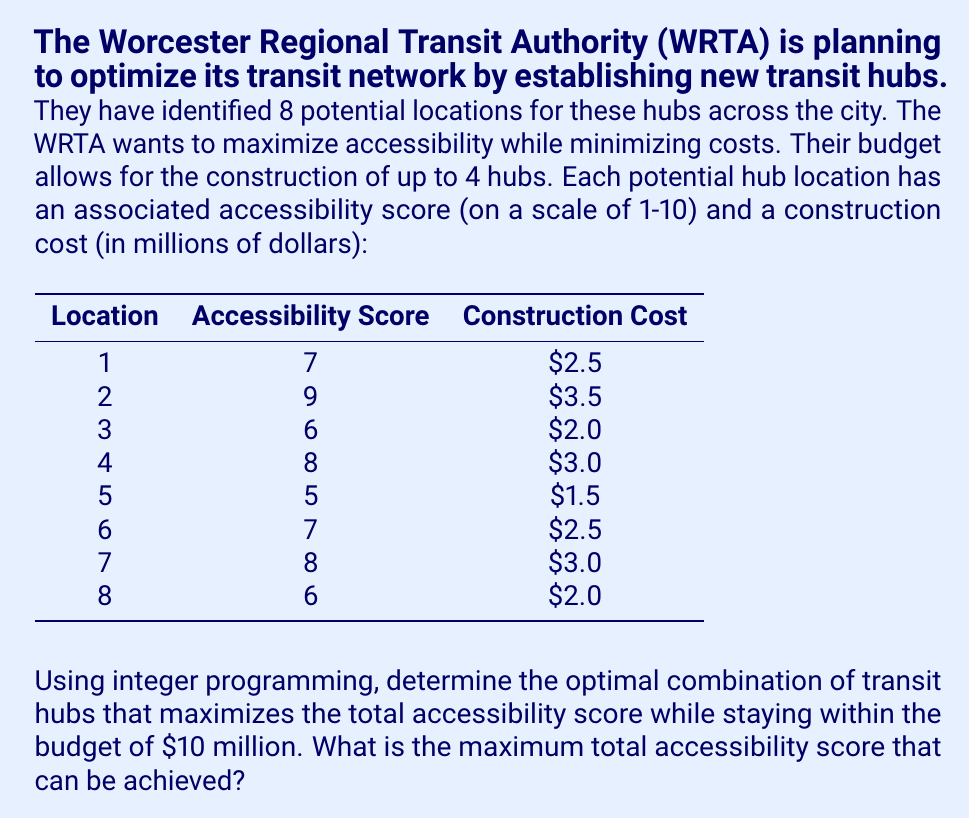Can you answer this question? To solve this problem, we'll use integer programming. Let's define our decision variables and formulate the problem:

Let $x_i$ be a binary variable for each location $i$ (1 if selected, 0 if not):

$$x_i \in \{0,1\}, \quad i = 1,2,\ldots,8$$

Objective function (maximize total accessibility score):

$$\text{Maximize } Z = 7x_1 + 9x_2 + 6x_3 + 8x_4 + 5x_5 + 7x_6 + 8x_7 + 6x_8$$

Constraints:

1. Budget constraint:
   $$2.5x_1 + 3.5x_2 + 2.0x_3 + 3.0x_4 + 1.5x_5 + 2.5x_6 + 3.0x_7 + 2.0x_8 \leq 10$$

2. Maximum number of hubs:
   $$x_1 + x_2 + x_3 + x_4 + x_5 + x_6 + x_7 + x_8 \leq 4$$

To solve this integer programming problem, we can use the branch and bound method or a solver. The optimal solution is:

$$x_1 = 1, x_2 = 1, x_4 = 1, x_7 = 0, x_3 = x_5 = x_6 = x_8 = 0$$

This solution selects locations 1, 2, and 4, resulting in:

Total accessibility score: $7 + 9 + 8 = 24$
Total cost: $2.5 + 3.5 + 3.0 = 9.0$ million (within budget)

We can verify that this is optimal by considering that location 2 has the highest accessibility score (9) and must be included. The remaining budget of $6.5 million is best spent on locations 1 and 4, which provide the highest combined accessibility score (7 + 8 = 15) within the budget.
Answer: The maximum total accessibility score that can be achieved is 24, by selecting transit hub locations 1, 2, and 4. 